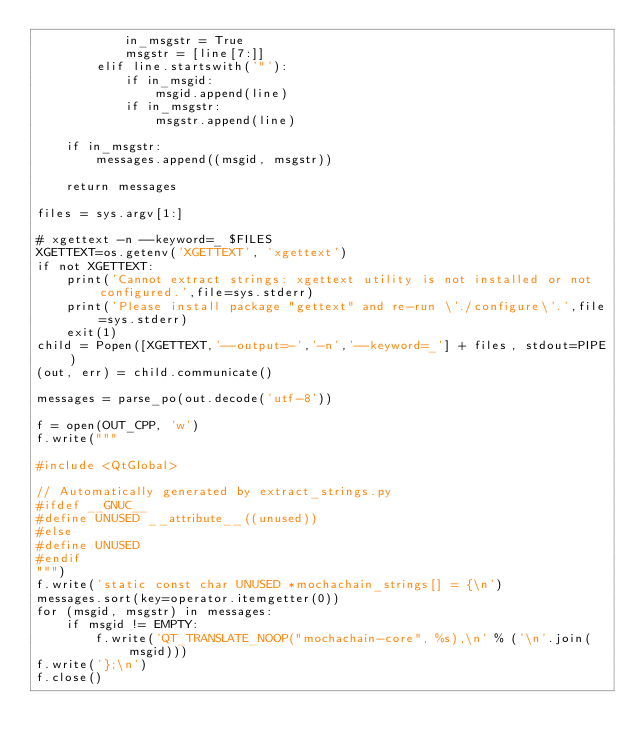<code> <loc_0><loc_0><loc_500><loc_500><_Python_>            in_msgstr = True
            msgstr = [line[7:]]
        elif line.startswith('"'):
            if in_msgid:
                msgid.append(line)
            if in_msgstr:
                msgstr.append(line)

    if in_msgstr:
        messages.append((msgid, msgstr))

    return messages

files = sys.argv[1:]

# xgettext -n --keyword=_ $FILES
XGETTEXT=os.getenv('XGETTEXT', 'xgettext')
if not XGETTEXT:
    print('Cannot extract strings: xgettext utility is not installed or not configured.',file=sys.stderr)
    print('Please install package "gettext" and re-run \'./configure\'.',file=sys.stderr)
    exit(1)
child = Popen([XGETTEXT,'--output=-','-n','--keyword=_'] + files, stdout=PIPE)
(out, err) = child.communicate()

messages = parse_po(out.decode('utf-8'))

f = open(OUT_CPP, 'w')
f.write("""

#include <QtGlobal>

// Automatically generated by extract_strings.py
#ifdef __GNUC__
#define UNUSED __attribute__((unused))
#else
#define UNUSED
#endif
""")
f.write('static const char UNUSED *mochachain_strings[] = {\n')
messages.sort(key=operator.itemgetter(0))
for (msgid, msgstr) in messages:
    if msgid != EMPTY:
        f.write('QT_TRANSLATE_NOOP("mochachain-core", %s),\n' % ('\n'.join(msgid)))
f.write('};\n')
f.close()
</code> 